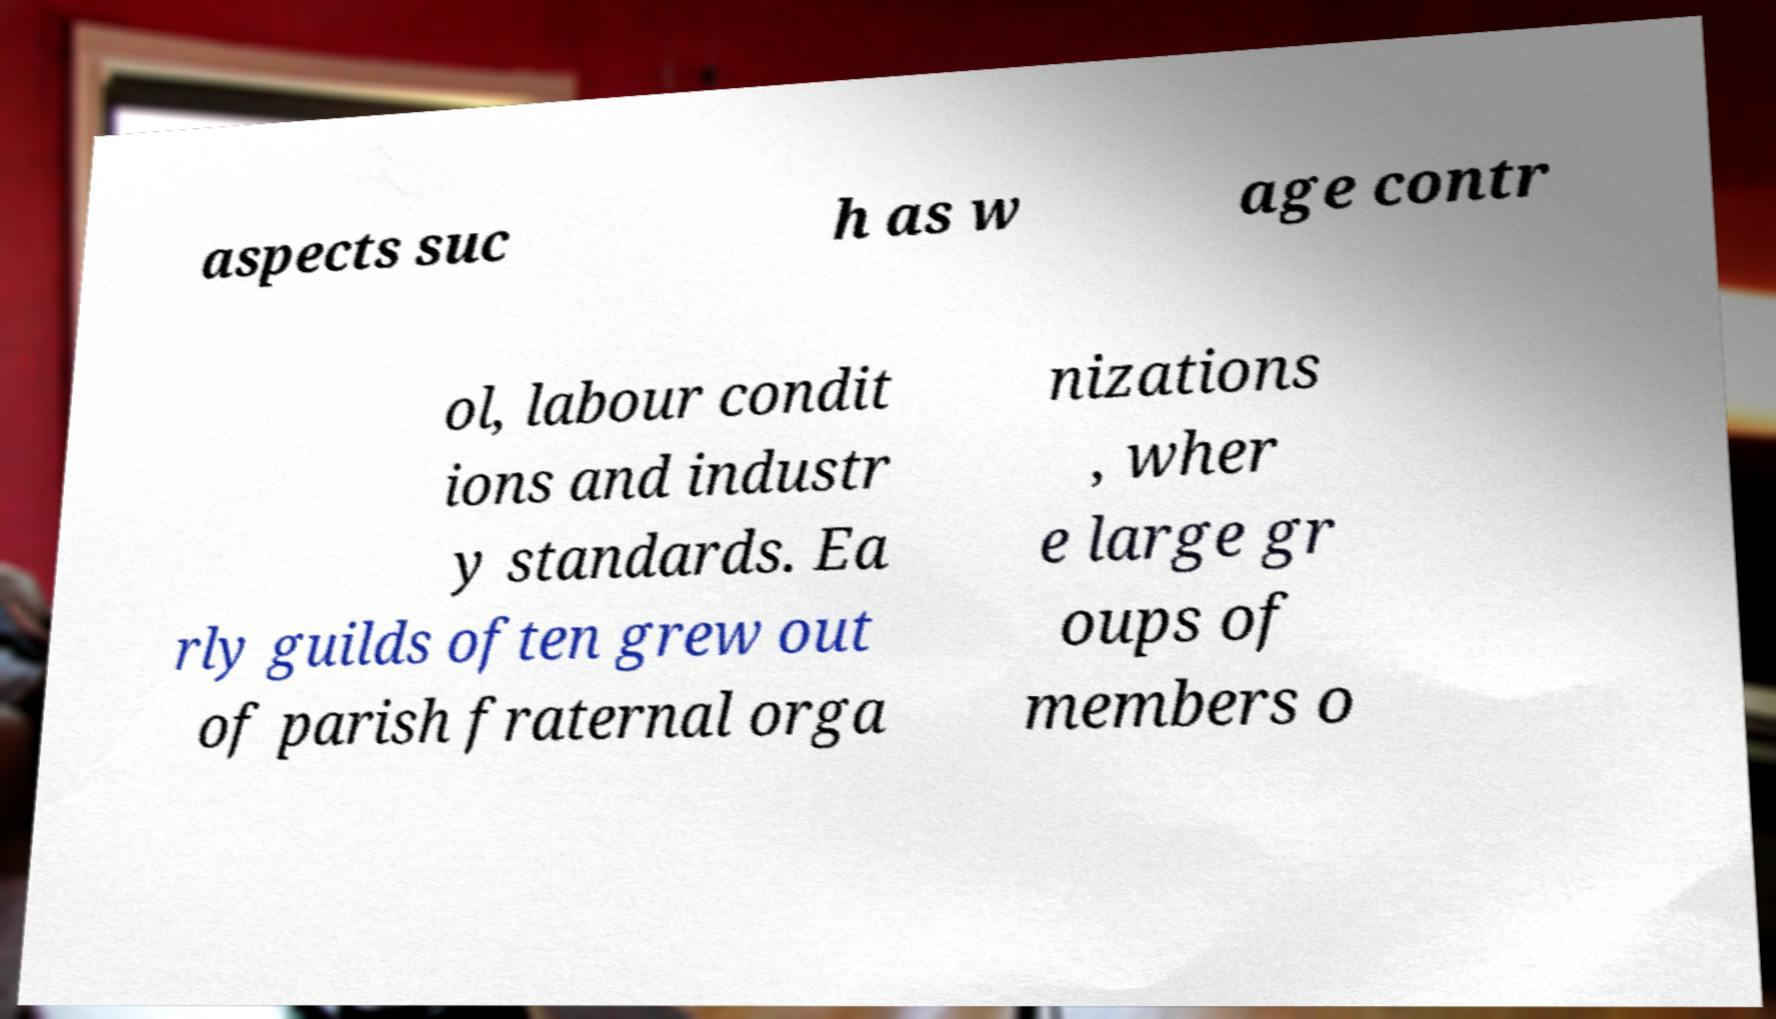There's text embedded in this image that I need extracted. Can you transcribe it verbatim? aspects suc h as w age contr ol, labour condit ions and industr y standards. Ea rly guilds often grew out of parish fraternal orga nizations , wher e large gr oups of members o 